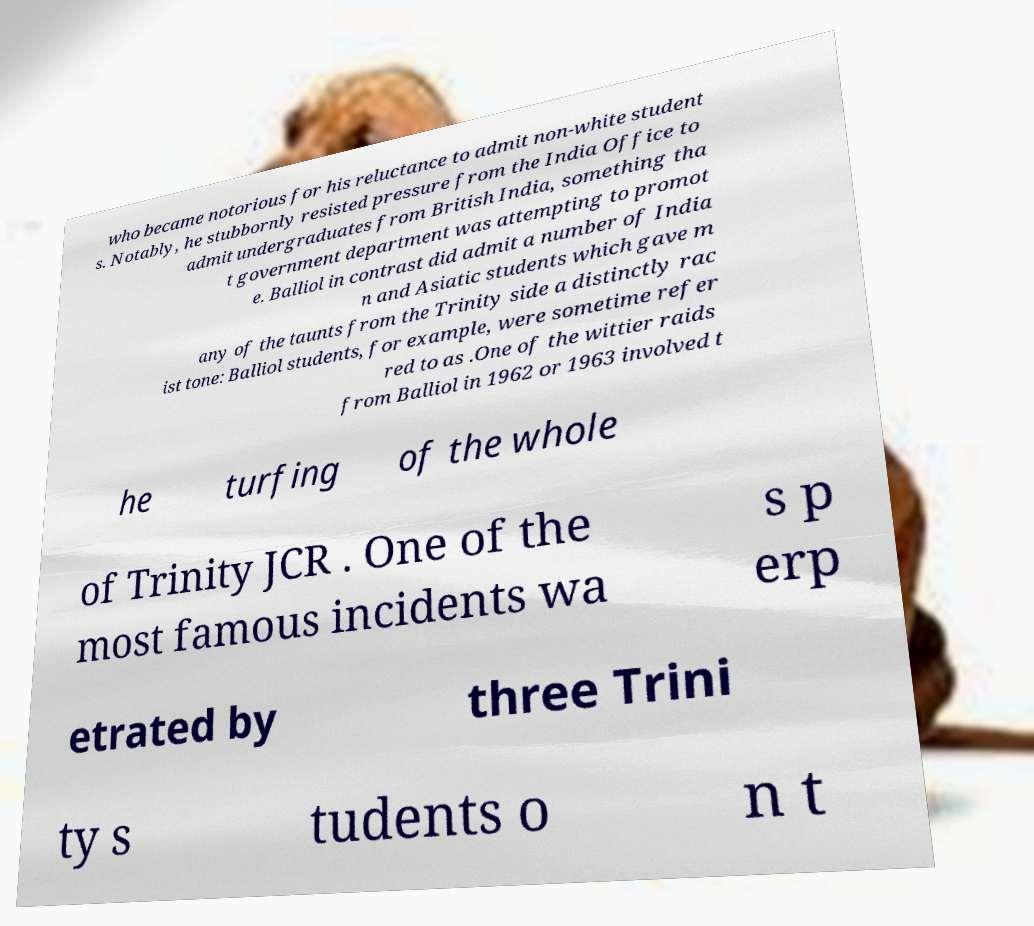For documentation purposes, I need the text within this image transcribed. Could you provide that? who became notorious for his reluctance to admit non-white student s. Notably, he stubbornly resisted pressure from the India Office to admit undergraduates from British India, something tha t government department was attempting to promot e. Balliol in contrast did admit a number of India n and Asiatic students which gave m any of the taunts from the Trinity side a distinctly rac ist tone: Balliol students, for example, were sometime refer red to as .One of the wittier raids from Balliol in 1962 or 1963 involved t he turfing of the whole of Trinity JCR . One of the most famous incidents wa s p erp etrated by three Trini ty s tudents o n t 